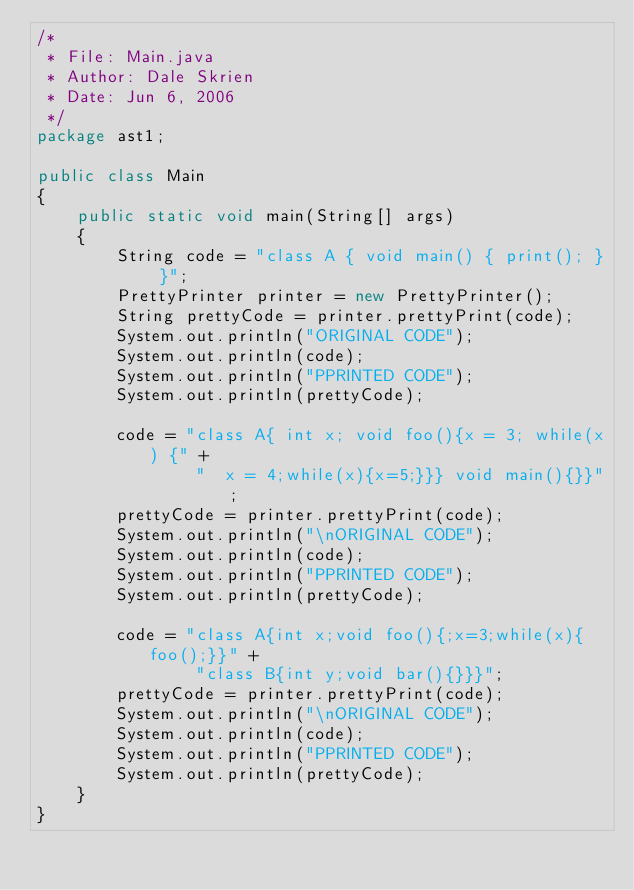<code> <loc_0><loc_0><loc_500><loc_500><_Java_>/*
 * File: Main.java
 * Author: Dale Skrien
 * Date: Jun 6, 2006
 */
package ast1;

public class Main
{
    public static void main(String[] args)
    {
        String code = "class A { void main() { print(); } }";
        PrettyPrinter printer = new PrettyPrinter();
        String prettyCode = printer.prettyPrint(code);
        System.out.println("ORIGINAL CODE");
        System.out.println(code);
        System.out.println("PPRINTED CODE");
        System.out.println(prettyCode);

        code = "class A{ int x; void foo(){x = 3; while(x) {" +
                "  x = 4;while(x){x=5;}}} void main(){}}";
        prettyCode = printer.prettyPrint(code);
        System.out.println("\nORIGINAL CODE");
        System.out.println(code);
        System.out.println("PPRINTED CODE");
        System.out.println(prettyCode);

        code = "class A{int x;void foo(){;x=3;while(x){foo();}}" +
                "class B{int y;void bar(){}}}";
        prettyCode = printer.prettyPrint(code);
        System.out.println("\nORIGINAL CODE");
        System.out.println(code);
        System.out.println("PPRINTED CODE");
        System.out.println(prettyCode);
    }
}
</code> 